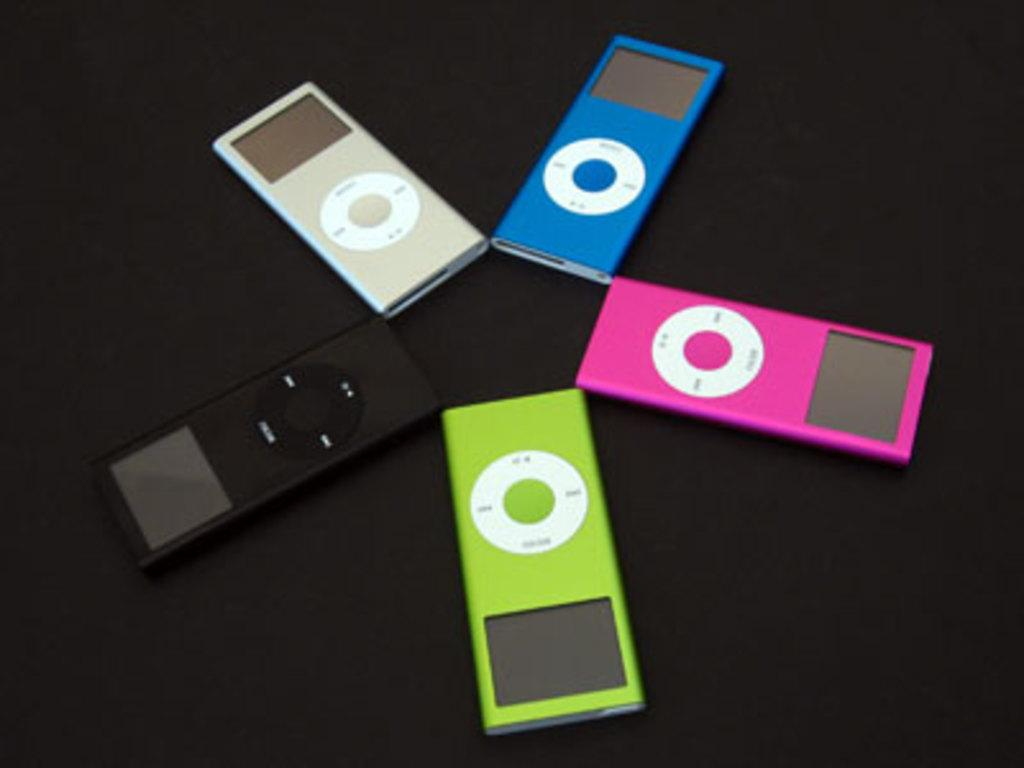What type of electronic device is visible in the image? There are airpods in the image. What is the aftermath of the grandfather's beginner gardening skills in the image? There is no mention of a grandfather or gardening in the image, so it is not possible to answer that question. 